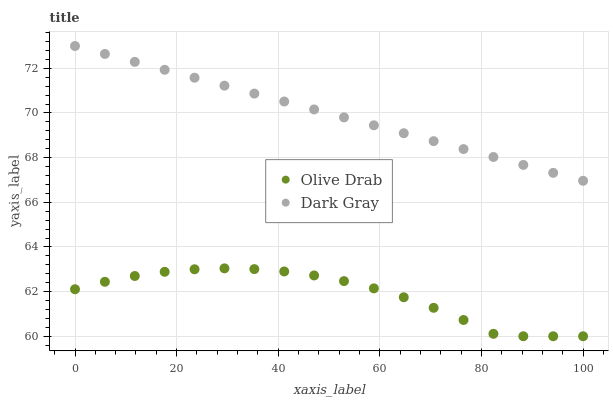Does Olive Drab have the minimum area under the curve?
Answer yes or no. Yes. Does Dark Gray have the maximum area under the curve?
Answer yes or no. Yes. Does Olive Drab have the maximum area under the curve?
Answer yes or no. No. Is Dark Gray the smoothest?
Answer yes or no. Yes. Is Olive Drab the roughest?
Answer yes or no. Yes. Is Olive Drab the smoothest?
Answer yes or no. No. Does Olive Drab have the lowest value?
Answer yes or no. Yes. Does Dark Gray have the highest value?
Answer yes or no. Yes. Does Olive Drab have the highest value?
Answer yes or no. No. Is Olive Drab less than Dark Gray?
Answer yes or no. Yes. Is Dark Gray greater than Olive Drab?
Answer yes or no. Yes. Does Olive Drab intersect Dark Gray?
Answer yes or no. No. 